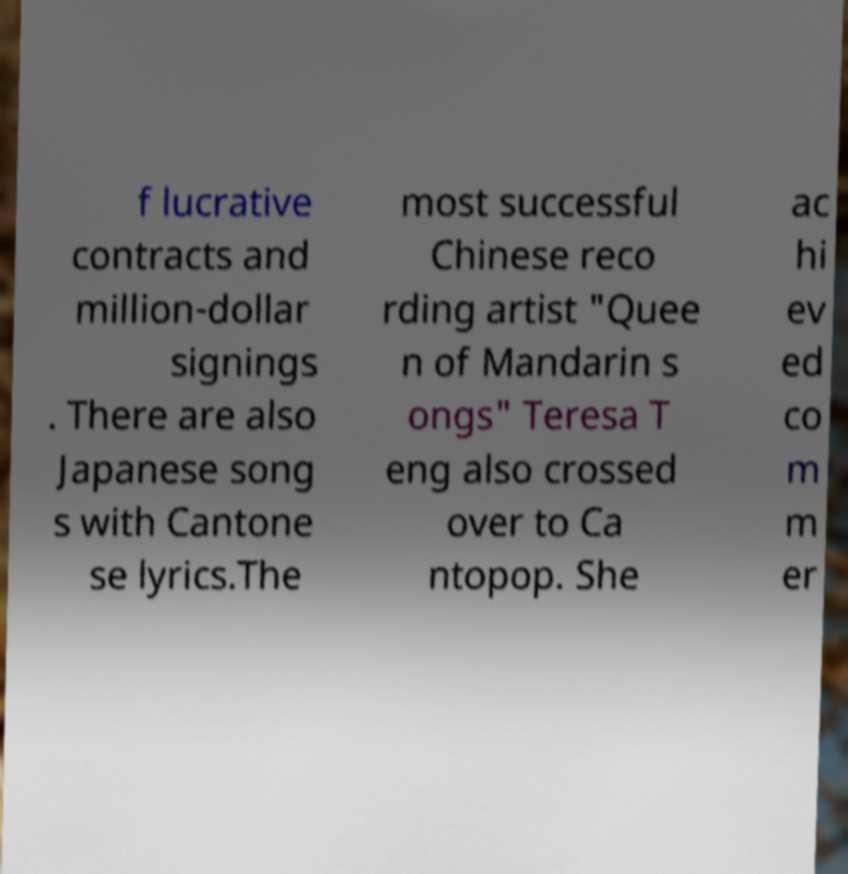What messages or text are displayed in this image? I need them in a readable, typed format. f lucrative contracts and million-dollar signings . There are also Japanese song s with Cantone se lyrics.The most successful Chinese reco rding artist "Quee n of Mandarin s ongs" Teresa T eng also crossed over to Ca ntopop. She ac hi ev ed co m m er 